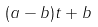Convert formula to latex. <formula><loc_0><loc_0><loc_500><loc_500>( a - b ) t + b</formula> 